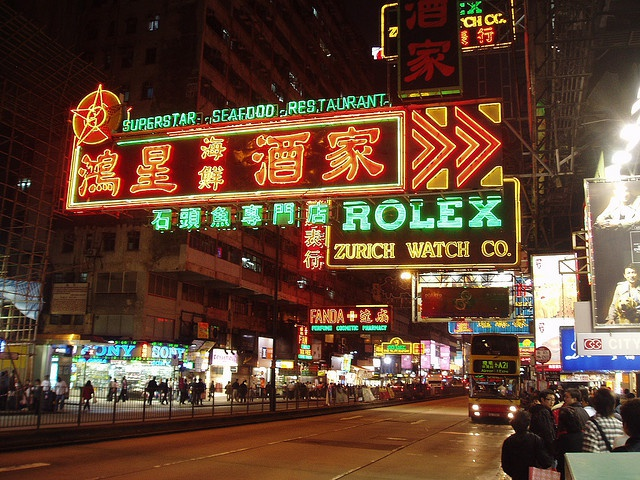Describe the objects in this image and their specific colors. I can see bus in black, maroon, olive, and brown tones, people in black, maroon, and gray tones, people in black, maroon, and brown tones, people in black, gray, and darkgray tones, and people in black, maroon, and gray tones in this image. 